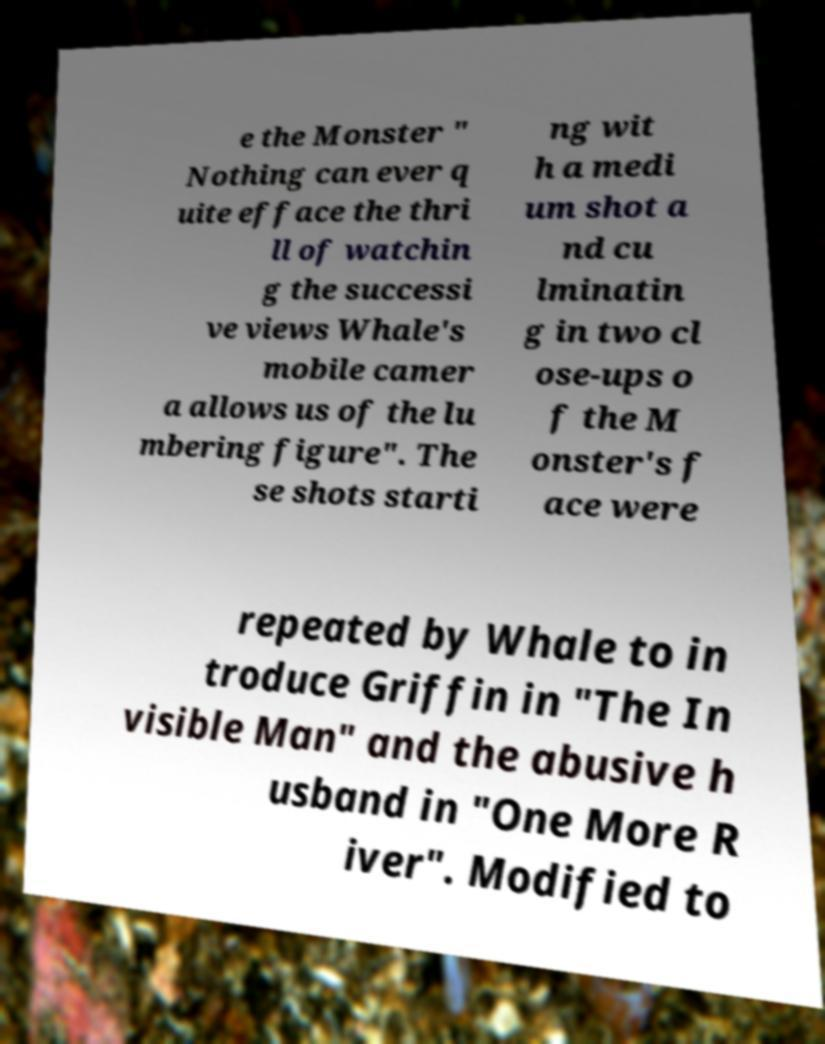Can you accurately transcribe the text from the provided image for me? e the Monster " Nothing can ever q uite efface the thri ll of watchin g the successi ve views Whale's mobile camer a allows us of the lu mbering figure". The se shots starti ng wit h a medi um shot a nd cu lminatin g in two cl ose-ups o f the M onster's f ace were repeated by Whale to in troduce Griffin in "The In visible Man" and the abusive h usband in "One More R iver". Modified to 